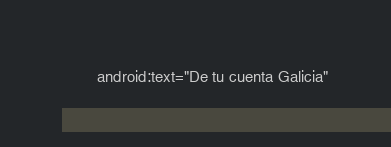<code> <loc_0><loc_0><loc_500><loc_500><_XML_>        android:text="De tu cuenta Galicia"</code> 